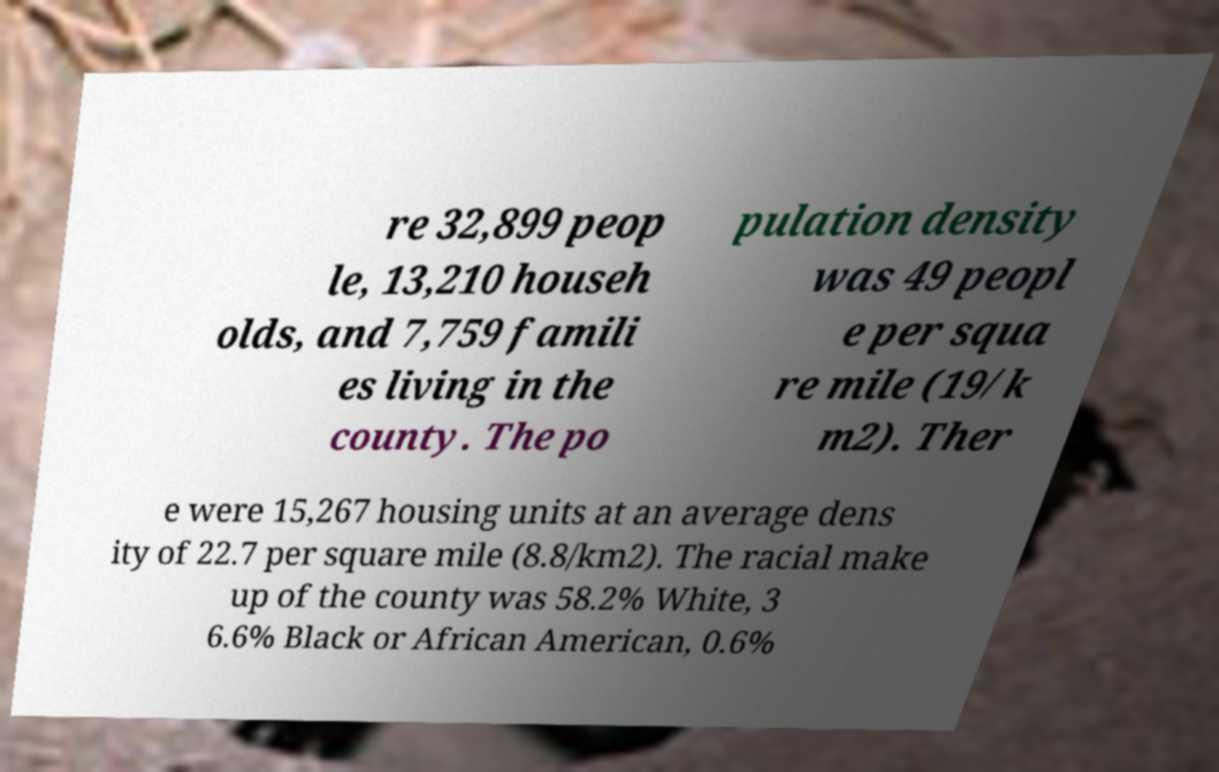Could you assist in decoding the text presented in this image and type it out clearly? re 32,899 peop le, 13,210 househ olds, and 7,759 famili es living in the county. The po pulation density was 49 peopl e per squa re mile (19/k m2). Ther e were 15,267 housing units at an average dens ity of 22.7 per square mile (8.8/km2). The racial make up of the county was 58.2% White, 3 6.6% Black or African American, 0.6% 